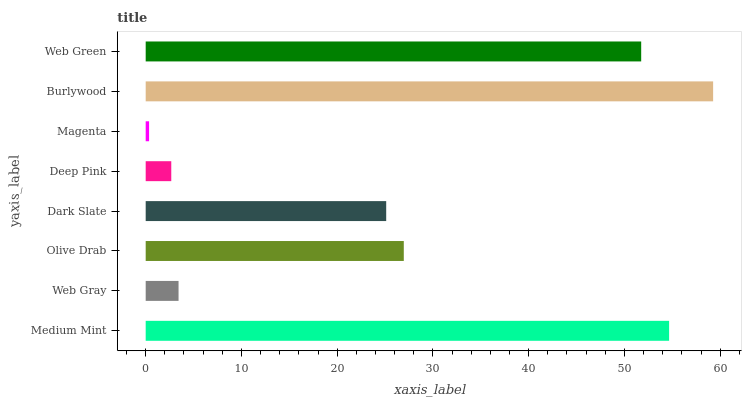Is Magenta the minimum?
Answer yes or no. Yes. Is Burlywood the maximum?
Answer yes or no. Yes. Is Web Gray the minimum?
Answer yes or no. No. Is Web Gray the maximum?
Answer yes or no. No. Is Medium Mint greater than Web Gray?
Answer yes or no. Yes. Is Web Gray less than Medium Mint?
Answer yes or no. Yes. Is Web Gray greater than Medium Mint?
Answer yes or no. No. Is Medium Mint less than Web Gray?
Answer yes or no. No. Is Olive Drab the high median?
Answer yes or no. Yes. Is Dark Slate the low median?
Answer yes or no. Yes. Is Magenta the high median?
Answer yes or no. No. Is Web Green the low median?
Answer yes or no. No. 